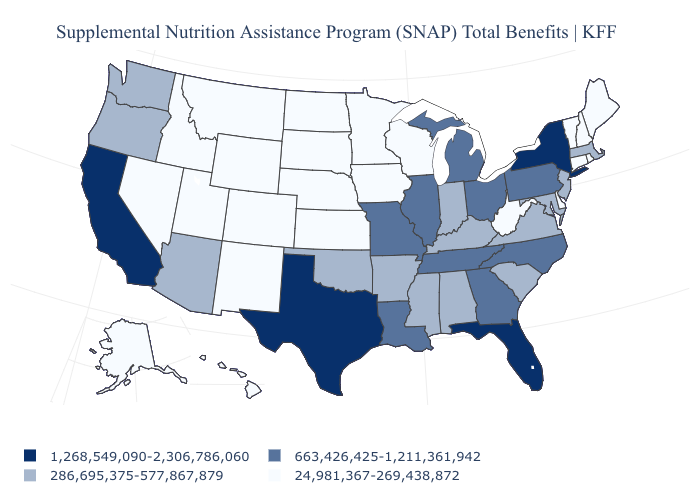What is the value of Ohio?
Give a very brief answer. 663,426,425-1,211,361,942. Name the states that have a value in the range 663,426,425-1,211,361,942?
Give a very brief answer. Georgia, Illinois, Louisiana, Michigan, Missouri, North Carolina, Ohio, Pennsylvania, Tennessee. What is the value of North Carolina?
Short answer required. 663,426,425-1,211,361,942. What is the value of Colorado?
Concise answer only. 24,981,367-269,438,872. What is the lowest value in states that border New Jersey?
Give a very brief answer. 24,981,367-269,438,872. Name the states that have a value in the range 286,695,375-577,867,879?
Answer briefly. Alabama, Arizona, Arkansas, Indiana, Kentucky, Maryland, Massachusetts, Mississippi, New Jersey, Oklahoma, Oregon, South Carolina, Virginia, Washington. Does Iowa have a lower value than Arkansas?
Short answer required. Yes. Does Minnesota have the lowest value in the USA?
Answer briefly. Yes. Does the first symbol in the legend represent the smallest category?
Quick response, please. No. Name the states that have a value in the range 286,695,375-577,867,879?
Give a very brief answer. Alabama, Arizona, Arkansas, Indiana, Kentucky, Maryland, Massachusetts, Mississippi, New Jersey, Oklahoma, Oregon, South Carolina, Virginia, Washington. Name the states that have a value in the range 24,981,367-269,438,872?
Short answer required. Alaska, Colorado, Connecticut, Delaware, Hawaii, Idaho, Iowa, Kansas, Maine, Minnesota, Montana, Nebraska, Nevada, New Hampshire, New Mexico, North Dakota, Rhode Island, South Dakota, Utah, Vermont, West Virginia, Wisconsin, Wyoming. What is the value of Kentucky?
Write a very short answer. 286,695,375-577,867,879. Does Nevada have a lower value than West Virginia?
Answer briefly. No. Name the states that have a value in the range 24,981,367-269,438,872?
Quick response, please. Alaska, Colorado, Connecticut, Delaware, Hawaii, Idaho, Iowa, Kansas, Maine, Minnesota, Montana, Nebraska, Nevada, New Hampshire, New Mexico, North Dakota, Rhode Island, South Dakota, Utah, Vermont, West Virginia, Wisconsin, Wyoming. Among the states that border Connecticut , which have the lowest value?
Give a very brief answer. Rhode Island. 